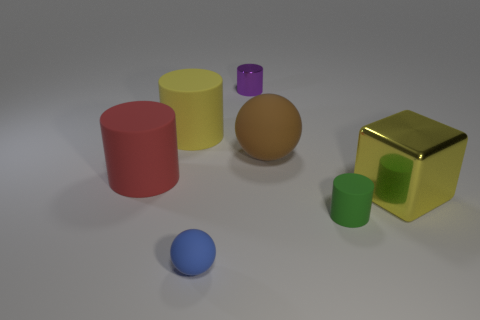What material is the large object that is the same color as the big cube?
Provide a succinct answer. Rubber. Is there anything else that has the same shape as the big metallic thing?
Your answer should be very brief. No. There is a object to the left of the large yellow rubber cylinder; what is it made of?
Offer a very short reply. Rubber. There is a big metallic object; are there any green rubber objects to the left of it?
Make the answer very short. Yes. What is the shape of the small purple object?
Offer a very short reply. Cylinder. How many things are green cylinders right of the small purple shiny object or yellow cylinders?
Keep it short and to the point. 2. How many other objects are there of the same color as the large cube?
Your answer should be compact. 1. There is a large metal block; does it have the same color as the matte cylinder that is behind the brown thing?
Your answer should be very brief. Yes. What color is the other thing that is the same shape as the blue thing?
Offer a terse response. Brown. Is the material of the small ball the same as the ball that is behind the blue rubber thing?
Provide a short and direct response. Yes. 